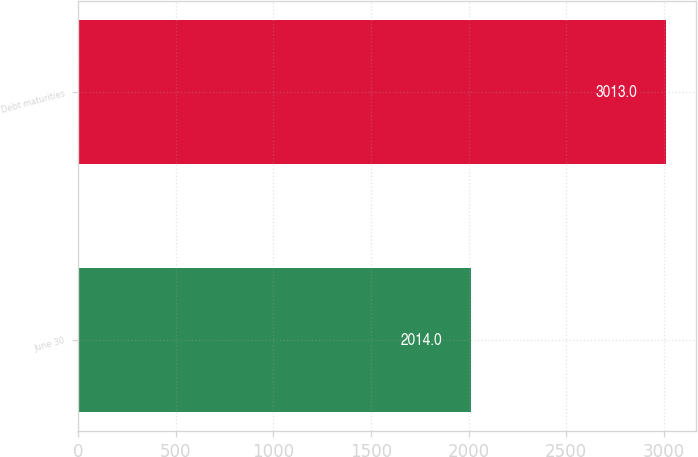Convert chart. <chart><loc_0><loc_0><loc_500><loc_500><bar_chart><fcel>June 30<fcel>Debt maturities<nl><fcel>2014<fcel>3013<nl></chart> 